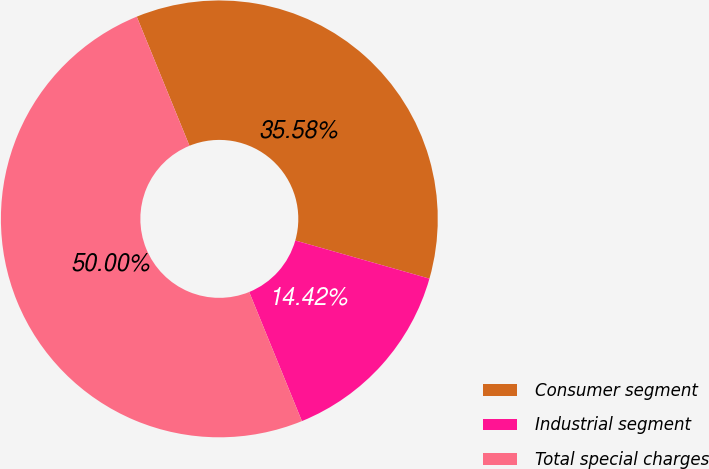<chart> <loc_0><loc_0><loc_500><loc_500><pie_chart><fcel>Consumer segment<fcel>Industrial segment<fcel>Total special charges<nl><fcel>35.58%<fcel>14.42%<fcel>50.0%<nl></chart> 